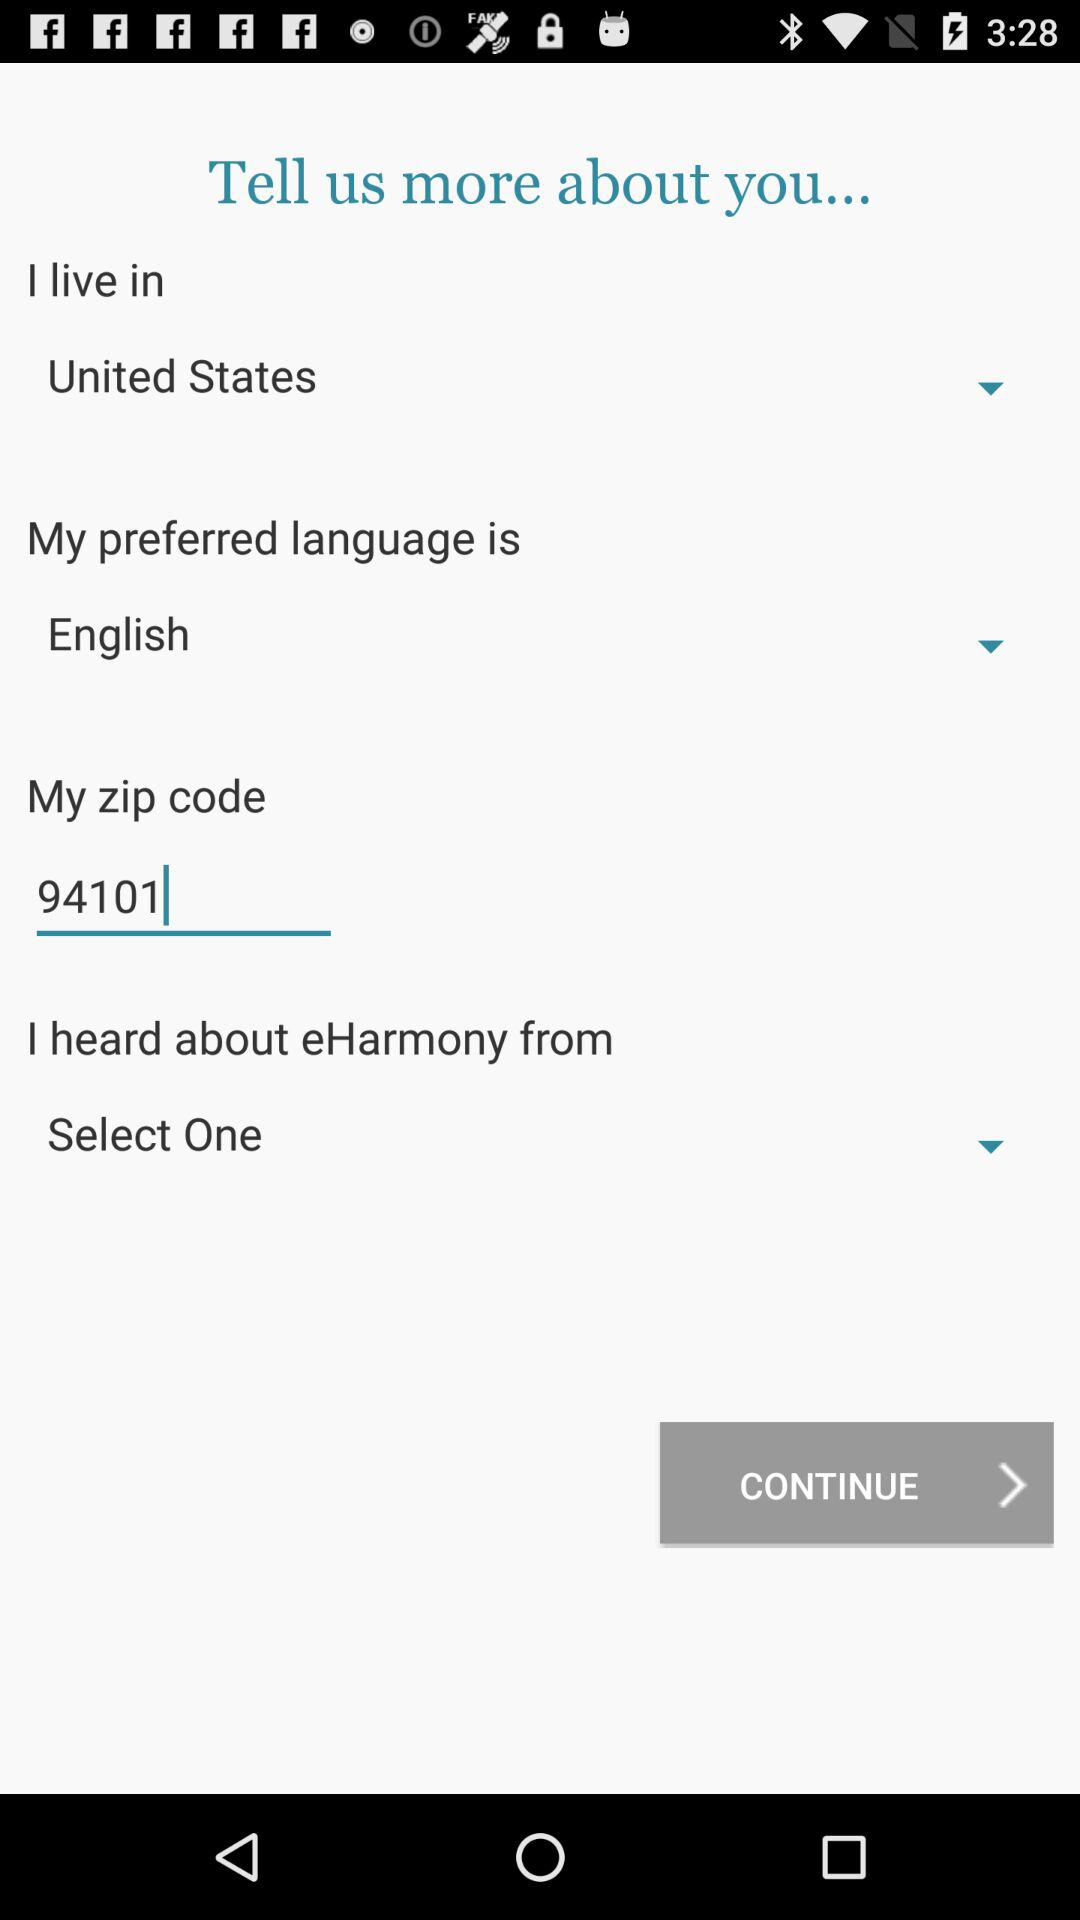What is the selected country? The selected country is the United States. 